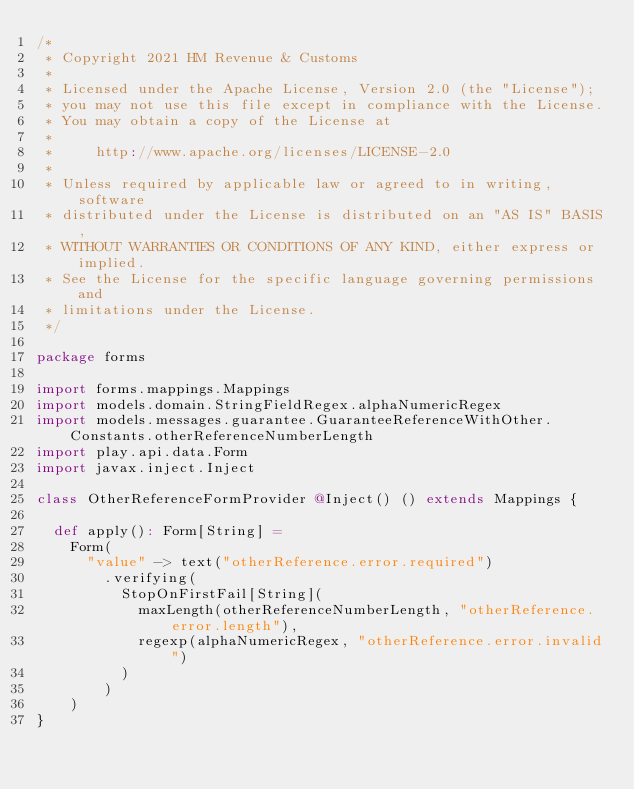<code> <loc_0><loc_0><loc_500><loc_500><_Scala_>/*
 * Copyright 2021 HM Revenue & Customs
 *
 * Licensed under the Apache License, Version 2.0 (the "License");
 * you may not use this file except in compliance with the License.
 * You may obtain a copy of the License at
 *
 *     http://www.apache.org/licenses/LICENSE-2.0
 *
 * Unless required by applicable law or agreed to in writing, software
 * distributed under the License is distributed on an "AS IS" BASIS,
 * WITHOUT WARRANTIES OR CONDITIONS OF ANY KIND, either express or implied.
 * See the License for the specific language governing permissions and
 * limitations under the License.
 */

package forms

import forms.mappings.Mappings
import models.domain.StringFieldRegex.alphaNumericRegex
import models.messages.guarantee.GuaranteeReferenceWithOther.Constants.otherReferenceNumberLength
import play.api.data.Form
import javax.inject.Inject

class OtherReferenceFormProvider @Inject() () extends Mappings {

  def apply(): Form[String] =
    Form(
      "value" -> text("otherReference.error.required")
        .verifying(
          StopOnFirstFail[String](
            maxLength(otherReferenceNumberLength, "otherReference.error.length"),
            regexp(alphaNumericRegex, "otherReference.error.invalid")
          )
        )
    )
}
</code> 